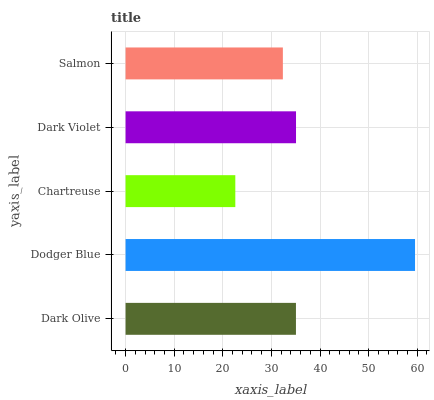Is Chartreuse the minimum?
Answer yes or no. Yes. Is Dodger Blue the maximum?
Answer yes or no. Yes. Is Dodger Blue the minimum?
Answer yes or no. No. Is Chartreuse the maximum?
Answer yes or no. No. Is Dodger Blue greater than Chartreuse?
Answer yes or no. Yes. Is Chartreuse less than Dodger Blue?
Answer yes or no. Yes. Is Chartreuse greater than Dodger Blue?
Answer yes or no. No. Is Dodger Blue less than Chartreuse?
Answer yes or no. No. Is Dark Olive the high median?
Answer yes or no. Yes. Is Dark Olive the low median?
Answer yes or no. Yes. Is Salmon the high median?
Answer yes or no. No. Is Chartreuse the low median?
Answer yes or no. No. 